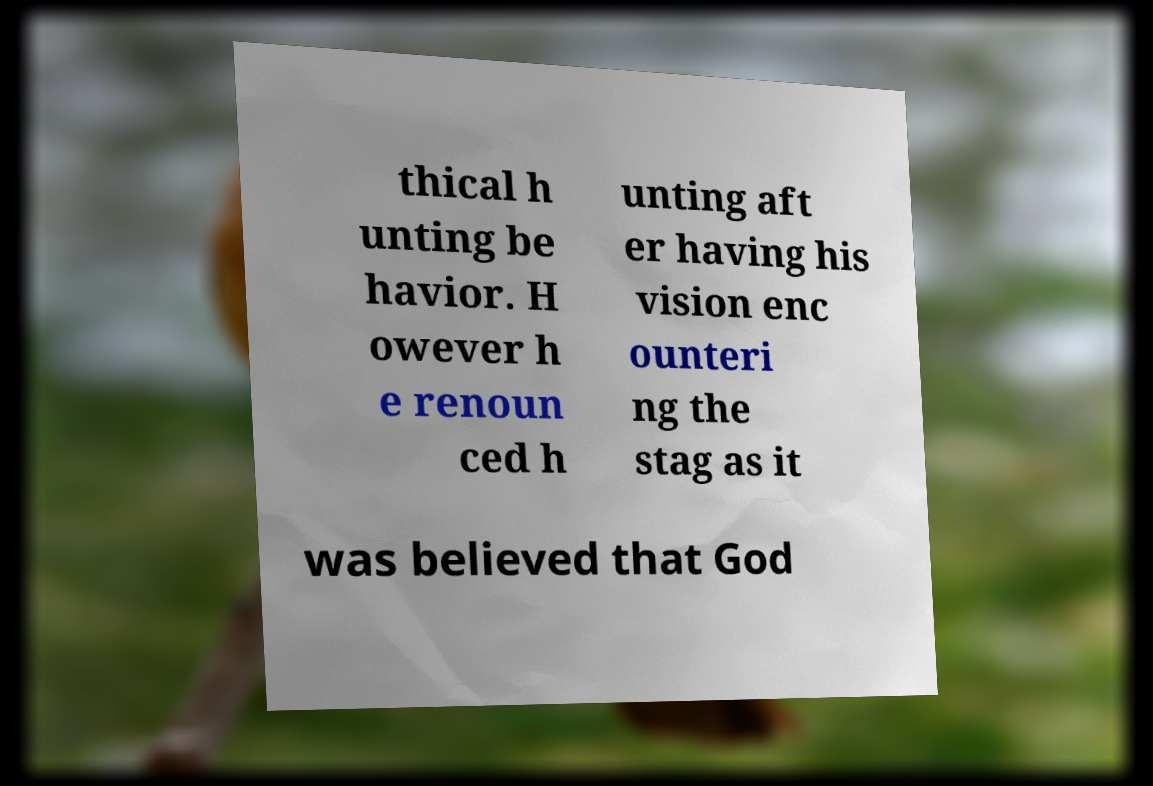Can you read and provide the text displayed in the image?This photo seems to have some interesting text. Can you extract and type it out for me? thical h unting be havior. H owever h e renoun ced h unting aft er having his vision enc ounteri ng the stag as it was believed that God 